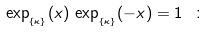<formula> <loc_0><loc_0><loc_500><loc_500>\exp _ { _ { \{ \kappa \} } } ( x ) \, \exp _ { _ { \{ \kappa \} } } ( - x ) = 1 \ \colon</formula> 